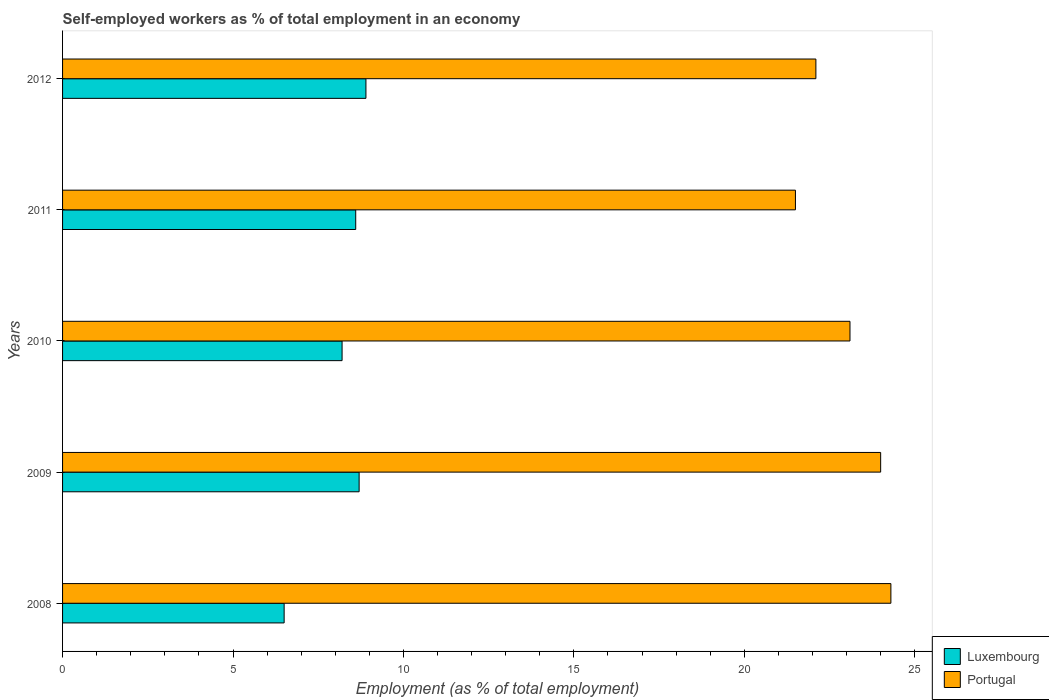How many different coloured bars are there?
Keep it short and to the point. 2. How many groups of bars are there?
Give a very brief answer. 5. Are the number of bars per tick equal to the number of legend labels?
Your answer should be very brief. Yes. How many bars are there on the 5th tick from the top?
Your answer should be very brief. 2. How many bars are there on the 4th tick from the bottom?
Your answer should be compact. 2. What is the label of the 2nd group of bars from the top?
Offer a very short reply. 2011. In how many cases, is the number of bars for a given year not equal to the number of legend labels?
Ensure brevity in your answer.  0. What is the percentage of self-employed workers in Portugal in 2012?
Keep it short and to the point. 22.1. Across all years, what is the maximum percentage of self-employed workers in Portugal?
Provide a succinct answer. 24.3. What is the total percentage of self-employed workers in Portugal in the graph?
Make the answer very short. 115. What is the difference between the percentage of self-employed workers in Luxembourg in 2008 and that in 2009?
Provide a succinct answer. -2.2. What is the difference between the percentage of self-employed workers in Luxembourg in 2011 and the percentage of self-employed workers in Portugal in 2012?
Provide a succinct answer. -13.5. What is the average percentage of self-employed workers in Portugal per year?
Keep it short and to the point. 23. In the year 2011, what is the difference between the percentage of self-employed workers in Luxembourg and percentage of self-employed workers in Portugal?
Offer a terse response. -12.9. In how many years, is the percentage of self-employed workers in Luxembourg greater than 9 %?
Offer a terse response. 0. What is the ratio of the percentage of self-employed workers in Luxembourg in 2011 to that in 2012?
Give a very brief answer. 0.97. Is the percentage of self-employed workers in Portugal in 2009 less than that in 2012?
Your answer should be compact. No. Is the difference between the percentage of self-employed workers in Luxembourg in 2009 and 2012 greater than the difference between the percentage of self-employed workers in Portugal in 2009 and 2012?
Your response must be concise. No. What is the difference between the highest and the second highest percentage of self-employed workers in Portugal?
Your answer should be compact. 0.3. What is the difference between the highest and the lowest percentage of self-employed workers in Portugal?
Your answer should be very brief. 2.8. In how many years, is the percentage of self-employed workers in Portugal greater than the average percentage of self-employed workers in Portugal taken over all years?
Your answer should be compact. 3. Is the sum of the percentage of self-employed workers in Portugal in 2011 and 2012 greater than the maximum percentage of self-employed workers in Luxembourg across all years?
Your answer should be very brief. Yes. What does the 1st bar from the top in 2008 represents?
Offer a very short reply. Portugal. What does the 1st bar from the bottom in 2011 represents?
Ensure brevity in your answer.  Luxembourg. How many years are there in the graph?
Make the answer very short. 5. What is the difference between two consecutive major ticks on the X-axis?
Your response must be concise. 5. How many legend labels are there?
Keep it short and to the point. 2. What is the title of the graph?
Make the answer very short. Self-employed workers as % of total employment in an economy. What is the label or title of the X-axis?
Your response must be concise. Employment (as % of total employment). What is the Employment (as % of total employment) of Luxembourg in 2008?
Give a very brief answer. 6.5. What is the Employment (as % of total employment) in Portugal in 2008?
Make the answer very short. 24.3. What is the Employment (as % of total employment) of Luxembourg in 2009?
Keep it short and to the point. 8.7. What is the Employment (as % of total employment) of Luxembourg in 2010?
Make the answer very short. 8.2. What is the Employment (as % of total employment) of Portugal in 2010?
Provide a short and direct response. 23.1. What is the Employment (as % of total employment) in Luxembourg in 2011?
Keep it short and to the point. 8.6. What is the Employment (as % of total employment) in Luxembourg in 2012?
Your answer should be compact. 8.9. What is the Employment (as % of total employment) of Portugal in 2012?
Offer a very short reply. 22.1. Across all years, what is the maximum Employment (as % of total employment) of Luxembourg?
Provide a succinct answer. 8.9. Across all years, what is the maximum Employment (as % of total employment) in Portugal?
Your answer should be compact. 24.3. Across all years, what is the minimum Employment (as % of total employment) in Luxembourg?
Your answer should be very brief. 6.5. Across all years, what is the minimum Employment (as % of total employment) of Portugal?
Provide a succinct answer. 21.5. What is the total Employment (as % of total employment) of Luxembourg in the graph?
Ensure brevity in your answer.  40.9. What is the total Employment (as % of total employment) of Portugal in the graph?
Make the answer very short. 115. What is the difference between the Employment (as % of total employment) of Luxembourg in 2008 and that in 2009?
Make the answer very short. -2.2. What is the difference between the Employment (as % of total employment) in Luxembourg in 2008 and that in 2010?
Your answer should be very brief. -1.7. What is the difference between the Employment (as % of total employment) in Portugal in 2008 and that in 2010?
Your answer should be very brief. 1.2. What is the difference between the Employment (as % of total employment) in Luxembourg in 2008 and that in 2011?
Give a very brief answer. -2.1. What is the difference between the Employment (as % of total employment) of Portugal in 2008 and that in 2011?
Provide a short and direct response. 2.8. What is the difference between the Employment (as % of total employment) of Luxembourg in 2008 and that in 2012?
Provide a succinct answer. -2.4. What is the difference between the Employment (as % of total employment) of Luxembourg in 2009 and that in 2010?
Offer a very short reply. 0.5. What is the difference between the Employment (as % of total employment) of Portugal in 2009 and that in 2010?
Provide a succinct answer. 0.9. What is the difference between the Employment (as % of total employment) in Luxembourg in 2009 and that in 2011?
Make the answer very short. 0.1. What is the difference between the Employment (as % of total employment) of Portugal in 2009 and that in 2011?
Make the answer very short. 2.5. What is the difference between the Employment (as % of total employment) in Luxembourg in 2009 and that in 2012?
Your response must be concise. -0.2. What is the difference between the Employment (as % of total employment) of Luxembourg in 2010 and that in 2011?
Keep it short and to the point. -0.4. What is the difference between the Employment (as % of total employment) in Portugal in 2010 and that in 2011?
Provide a succinct answer. 1.6. What is the difference between the Employment (as % of total employment) of Luxembourg in 2010 and that in 2012?
Offer a terse response. -0.7. What is the difference between the Employment (as % of total employment) of Portugal in 2010 and that in 2012?
Your answer should be compact. 1. What is the difference between the Employment (as % of total employment) in Luxembourg in 2011 and that in 2012?
Provide a short and direct response. -0.3. What is the difference between the Employment (as % of total employment) in Luxembourg in 2008 and the Employment (as % of total employment) in Portugal in 2009?
Provide a succinct answer. -17.5. What is the difference between the Employment (as % of total employment) of Luxembourg in 2008 and the Employment (as % of total employment) of Portugal in 2010?
Ensure brevity in your answer.  -16.6. What is the difference between the Employment (as % of total employment) of Luxembourg in 2008 and the Employment (as % of total employment) of Portugal in 2011?
Offer a very short reply. -15. What is the difference between the Employment (as % of total employment) of Luxembourg in 2008 and the Employment (as % of total employment) of Portugal in 2012?
Your response must be concise. -15.6. What is the difference between the Employment (as % of total employment) in Luxembourg in 2009 and the Employment (as % of total employment) in Portugal in 2010?
Make the answer very short. -14.4. What is the difference between the Employment (as % of total employment) of Luxembourg in 2009 and the Employment (as % of total employment) of Portugal in 2012?
Your response must be concise. -13.4. What is the difference between the Employment (as % of total employment) in Luxembourg in 2010 and the Employment (as % of total employment) in Portugal in 2011?
Give a very brief answer. -13.3. What is the average Employment (as % of total employment) in Luxembourg per year?
Your answer should be compact. 8.18. What is the average Employment (as % of total employment) of Portugal per year?
Provide a short and direct response. 23. In the year 2008, what is the difference between the Employment (as % of total employment) of Luxembourg and Employment (as % of total employment) of Portugal?
Offer a terse response. -17.8. In the year 2009, what is the difference between the Employment (as % of total employment) in Luxembourg and Employment (as % of total employment) in Portugal?
Ensure brevity in your answer.  -15.3. In the year 2010, what is the difference between the Employment (as % of total employment) of Luxembourg and Employment (as % of total employment) of Portugal?
Your answer should be compact. -14.9. In the year 2012, what is the difference between the Employment (as % of total employment) of Luxembourg and Employment (as % of total employment) of Portugal?
Make the answer very short. -13.2. What is the ratio of the Employment (as % of total employment) of Luxembourg in 2008 to that in 2009?
Keep it short and to the point. 0.75. What is the ratio of the Employment (as % of total employment) of Portugal in 2008 to that in 2009?
Provide a short and direct response. 1.01. What is the ratio of the Employment (as % of total employment) of Luxembourg in 2008 to that in 2010?
Your answer should be compact. 0.79. What is the ratio of the Employment (as % of total employment) of Portugal in 2008 to that in 2010?
Ensure brevity in your answer.  1.05. What is the ratio of the Employment (as % of total employment) in Luxembourg in 2008 to that in 2011?
Offer a terse response. 0.76. What is the ratio of the Employment (as % of total employment) in Portugal in 2008 to that in 2011?
Provide a succinct answer. 1.13. What is the ratio of the Employment (as % of total employment) in Luxembourg in 2008 to that in 2012?
Your answer should be compact. 0.73. What is the ratio of the Employment (as % of total employment) of Portugal in 2008 to that in 2012?
Your response must be concise. 1.1. What is the ratio of the Employment (as % of total employment) in Luxembourg in 2009 to that in 2010?
Your response must be concise. 1.06. What is the ratio of the Employment (as % of total employment) in Portugal in 2009 to that in 2010?
Your answer should be compact. 1.04. What is the ratio of the Employment (as % of total employment) in Luxembourg in 2009 to that in 2011?
Offer a terse response. 1.01. What is the ratio of the Employment (as % of total employment) in Portugal in 2009 to that in 2011?
Give a very brief answer. 1.12. What is the ratio of the Employment (as % of total employment) in Luxembourg in 2009 to that in 2012?
Ensure brevity in your answer.  0.98. What is the ratio of the Employment (as % of total employment) in Portugal in 2009 to that in 2012?
Provide a short and direct response. 1.09. What is the ratio of the Employment (as % of total employment) of Luxembourg in 2010 to that in 2011?
Provide a succinct answer. 0.95. What is the ratio of the Employment (as % of total employment) of Portugal in 2010 to that in 2011?
Your answer should be very brief. 1.07. What is the ratio of the Employment (as % of total employment) of Luxembourg in 2010 to that in 2012?
Make the answer very short. 0.92. What is the ratio of the Employment (as % of total employment) of Portugal in 2010 to that in 2012?
Ensure brevity in your answer.  1.05. What is the ratio of the Employment (as % of total employment) in Luxembourg in 2011 to that in 2012?
Offer a terse response. 0.97. What is the ratio of the Employment (as % of total employment) of Portugal in 2011 to that in 2012?
Your answer should be compact. 0.97. What is the difference between the highest and the lowest Employment (as % of total employment) of Luxembourg?
Offer a very short reply. 2.4. 